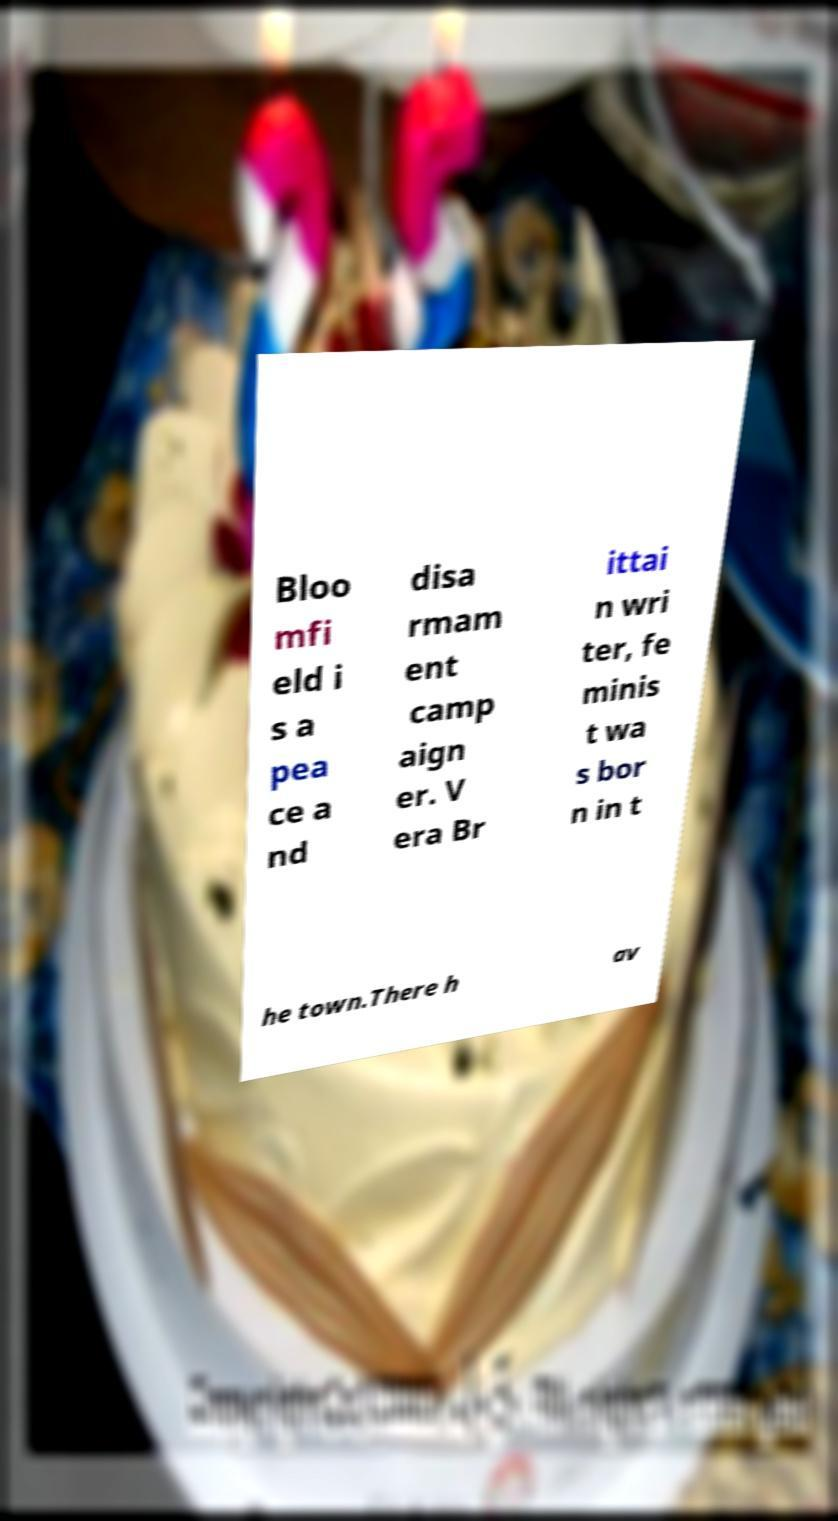Please identify and transcribe the text found in this image. Bloo mfi eld i s a pea ce a nd disa rmam ent camp aign er. V era Br ittai n wri ter, fe minis t wa s bor n in t he town.There h av 